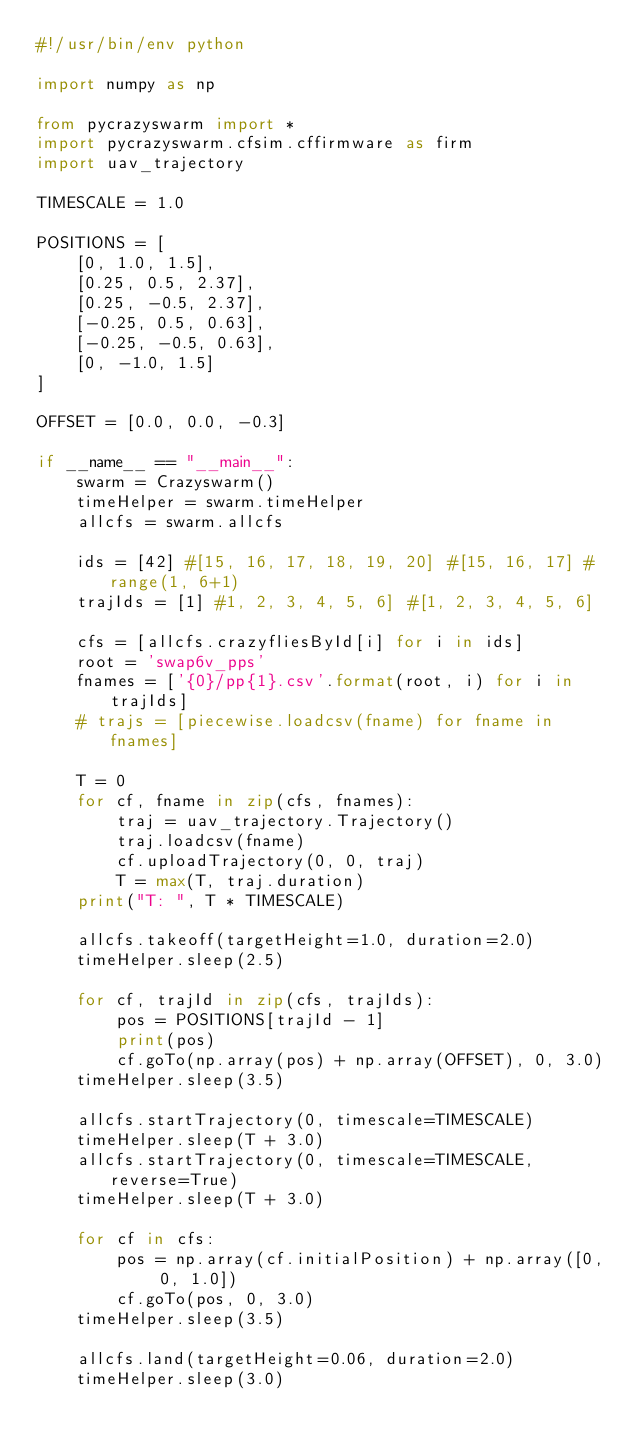Convert code to text. <code><loc_0><loc_0><loc_500><loc_500><_Python_>#!/usr/bin/env python

import numpy as np

from pycrazyswarm import *
import pycrazyswarm.cfsim.cffirmware as firm
import uav_trajectory

TIMESCALE = 1.0

POSITIONS = [
    [0, 1.0, 1.5],
    [0.25, 0.5, 2.37],
    [0.25, -0.5, 2.37],
    [-0.25, 0.5, 0.63],
    [-0.25, -0.5, 0.63],
    [0, -1.0, 1.5]
]

OFFSET = [0.0, 0.0, -0.3]

if __name__ == "__main__":
    swarm = Crazyswarm()
    timeHelper = swarm.timeHelper
    allcfs = swarm.allcfs

    ids = [42] #[15, 16, 17, 18, 19, 20] #[15, 16, 17] #range(1, 6+1)
    trajIds = [1] #1, 2, 3, 4, 5, 6] #[1, 2, 3, 4, 5, 6]

    cfs = [allcfs.crazyfliesById[i] for i in ids]
    root = 'swap6v_pps'
    fnames = ['{0}/pp{1}.csv'.format(root, i) for i in trajIds]
    # trajs = [piecewise.loadcsv(fname) for fname in fnames]

    T = 0
    for cf, fname in zip(cfs, fnames):
        traj = uav_trajectory.Trajectory()
        traj.loadcsv(fname)
        cf.uploadTrajectory(0, 0, traj)
        T = max(T, traj.duration)
    print("T: ", T * TIMESCALE)

    allcfs.takeoff(targetHeight=1.0, duration=2.0)
    timeHelper.sleep(2.5)

    for cf, trajId in zip(cfs, trajIds):
        pos = POSITIONS[trajId - 1]
        print(pos)
        cf.goTo(np.array(pos) + np.array(OFFSET), 0, 3.0)
    timeHelper.sleep(3.5)

    allcfs.startTrajectory(0, timescale=TIMESCALE)
    timeHelper.sleep(T + 3.0)
    allcfs.startTrajectory(0, timescale=TIMESCALE, reverse=True)
    timeHelper.sleep(T + 3.0)

    for cf in cfs:
        pos = np.array(cf.initialPosition) + np.array([0, 0, 1.0])
        cf.goTo(pos, 0, 3.0)
    timeHelper.sleep(3.5)

    allcfs.land(targetHeight=0.06, duration=2.0)
    timeHelper.sleep(3.0)

</code> 